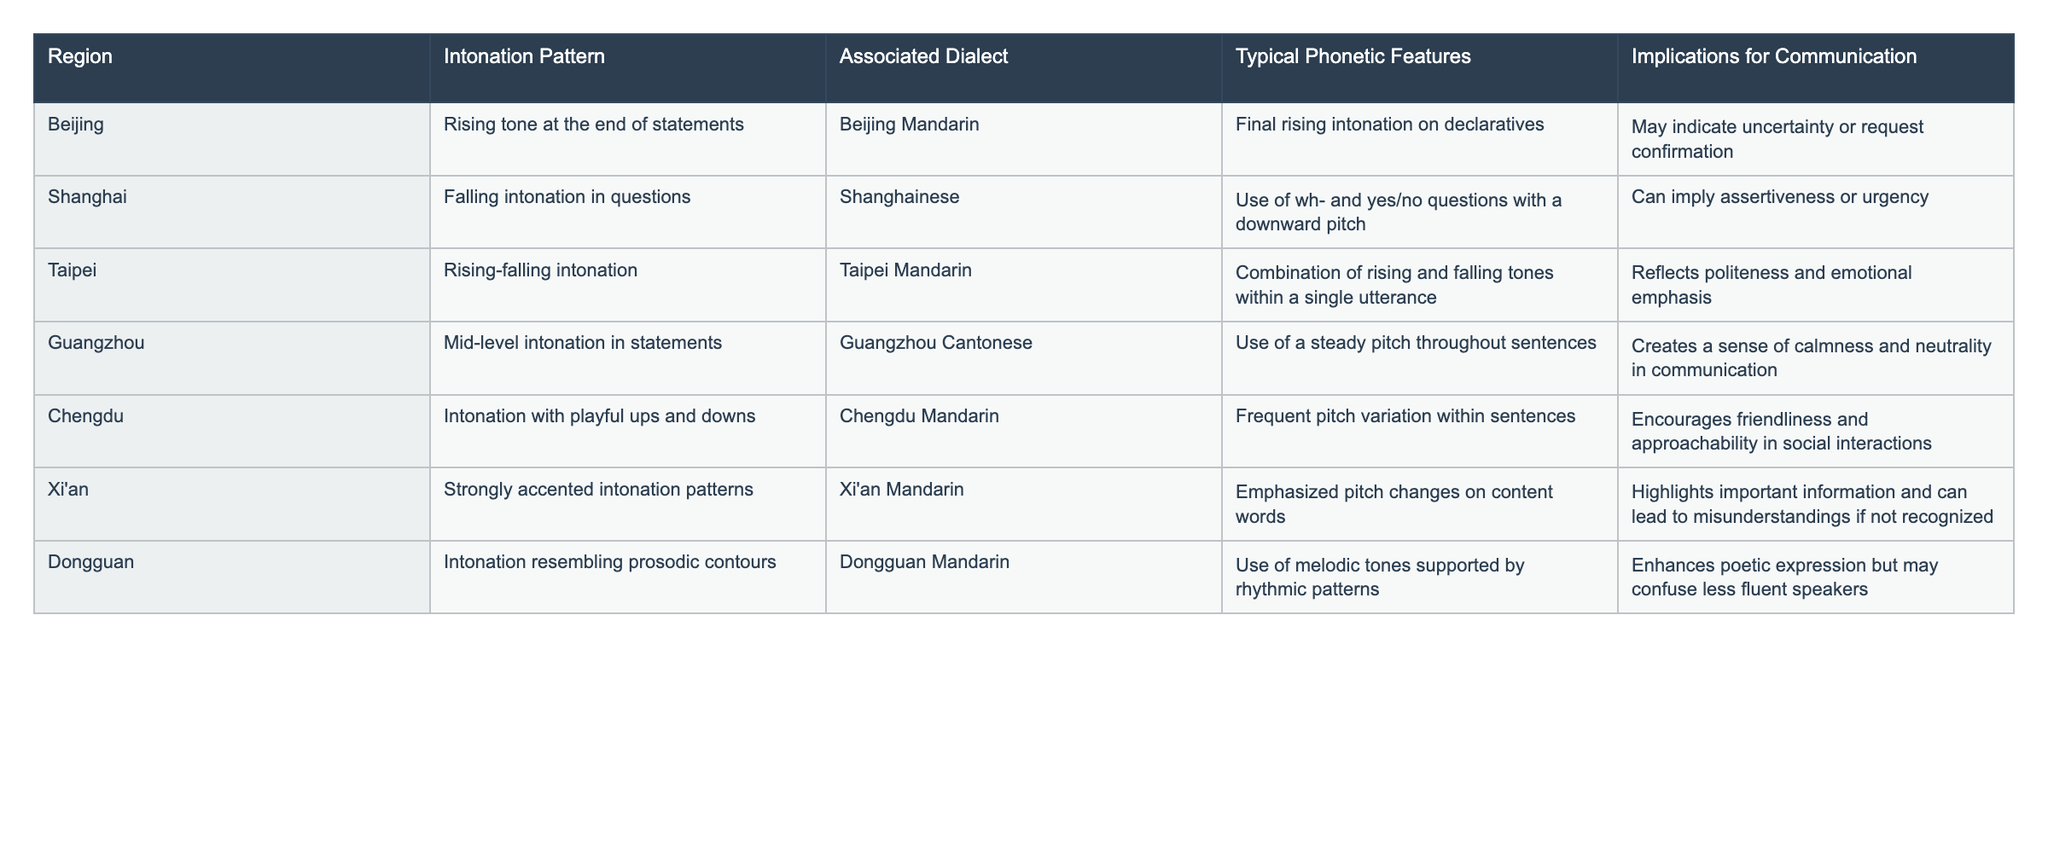What intonation pattern is associated with Beijing? By looking at the table under the "Region" column for Beijing, the corresponding "Intonation Pattern" is noted. It states "Rising tone at the end of statements."
Answer: Rising tone at the end of statements Which region exhibits a falling intonation in questions? Referring to the "Intonation Pattern" column, we see that "Falling intonation in questions" is listed next to the "Shanghai" region.
Answer: Shanghai True or False: Taipei Mandarin has a mid-level intonation pattern in statements. The table specifies that "Mid-level intonation in statements" is associated with "Guangzhou Cantonese," not Taipei Mandarin, making this statement false.
Answer: False What are the implications for communication in Chengdu? The table provides the "Implications for Communication" for Chengdu's intonation pattern, which states that it "Encourages friendliness and approachability in social interactions."
Answer: Encourages friendliness and approachability How many regions use intonation patterns that imply assertiveness or urgency? The table indicates that only one region, Shanghai, uses an intonation pattern that implies assertiveness or urgency. Therefore, the total count is one.
Answer: 1 Which dialect, according to the table, reflects politeness and emotional emphasis? In the "Associated Dialect" column, Taipei Mandarin is aligned with the "Rising-falling intonation," which reflects politeness and emotional emphasis.
Answer: Taipei Mandarin What is the implication of the intonation resembling prosodic contours according to the table? The "Implications for Communication" section reveals that this intonation enhances poetic expression but can confuse less fluent speakers.
Answer: Enhances poetic expression but may confuse less fluent speakers Identify the region where the intonation has playful ups and downs. Looking at the "Intonation Pattern" for Chengdu, we see it described as "Intonation with playful ups and downs."
Answer: Chengdu How does the Guangzhou intonation pattern contribute to communication? The steady pitch throughout sentences creates a sense of calmness and neutrality in communication, as noted in the implications section for Guangzhou.
Answer: Creates calmness and neutrality in communication If someone speaks with a strongly accented intonation pattern, which region are they likely from? The "Intonation Pattern" for Xi'an indicates "Strongly accented intonation patterns," indicating that a person speaking this way is likely from Xi'an.
Answer: Xi'an 